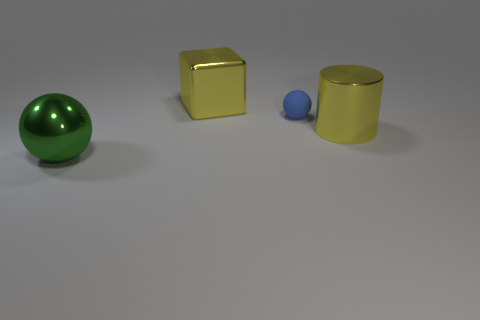What number of blue balls are the same material as the yellow cylinder?
Make the answer very short. 0. Is the shape of the green shiny thing to the left of the tiny matte object the same as  the blue object?
Provide a succinct answer. Yes. There is a big yellow thing that is on the left side of the blue object; what is its shape?
Provide a succinct answer. Cube. What is the blue ball made of?
Your answer should be compact. Rubber. The metallic block that is the same size as the yellow shiny cylinder is what color?
Give a very brief answer. Yellow. What shape is the big metallic thing that is the same color as the block?
Keep it short and to the point. Cylinder. Does the small thing have the same shape as the green object?
Your answer should be compact. Yes. What material is the large object that is both in front of the blue object and to the left of the blue matte thing?
Make the answer very short. Metal. What is the size of the yellow cylinder?
Make the answer very short. Large. What is the color of the other thing that is the same shape as the matte object?
Offer a terse response. Green. 